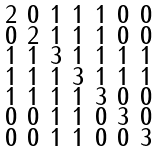Convert formula to latex. <formula><loc_0><loc_0><loc_500><loc_500>\begin{smallmatrix} 2 & 0 & 1 & 1 & 1 & 0 & 0 \\ 0 & 2 & 1 & 1 & 1 & 0 & 0 \\ 1 & 1 & 3 & 1 & 1 & 1 & 1 \\ 1 & 1 & 1 & 3 & 1 & 1 & 1 \\ 1 & 1 & 1 & 1 & 3 & 0 & 0 \\ 0 & 0 & 1 & 1 & 0 & 3 & 0 \\ 0 & 0 & 1 & 1 & 0 & 0 & 3 \end{smallmatrix}</formula> 